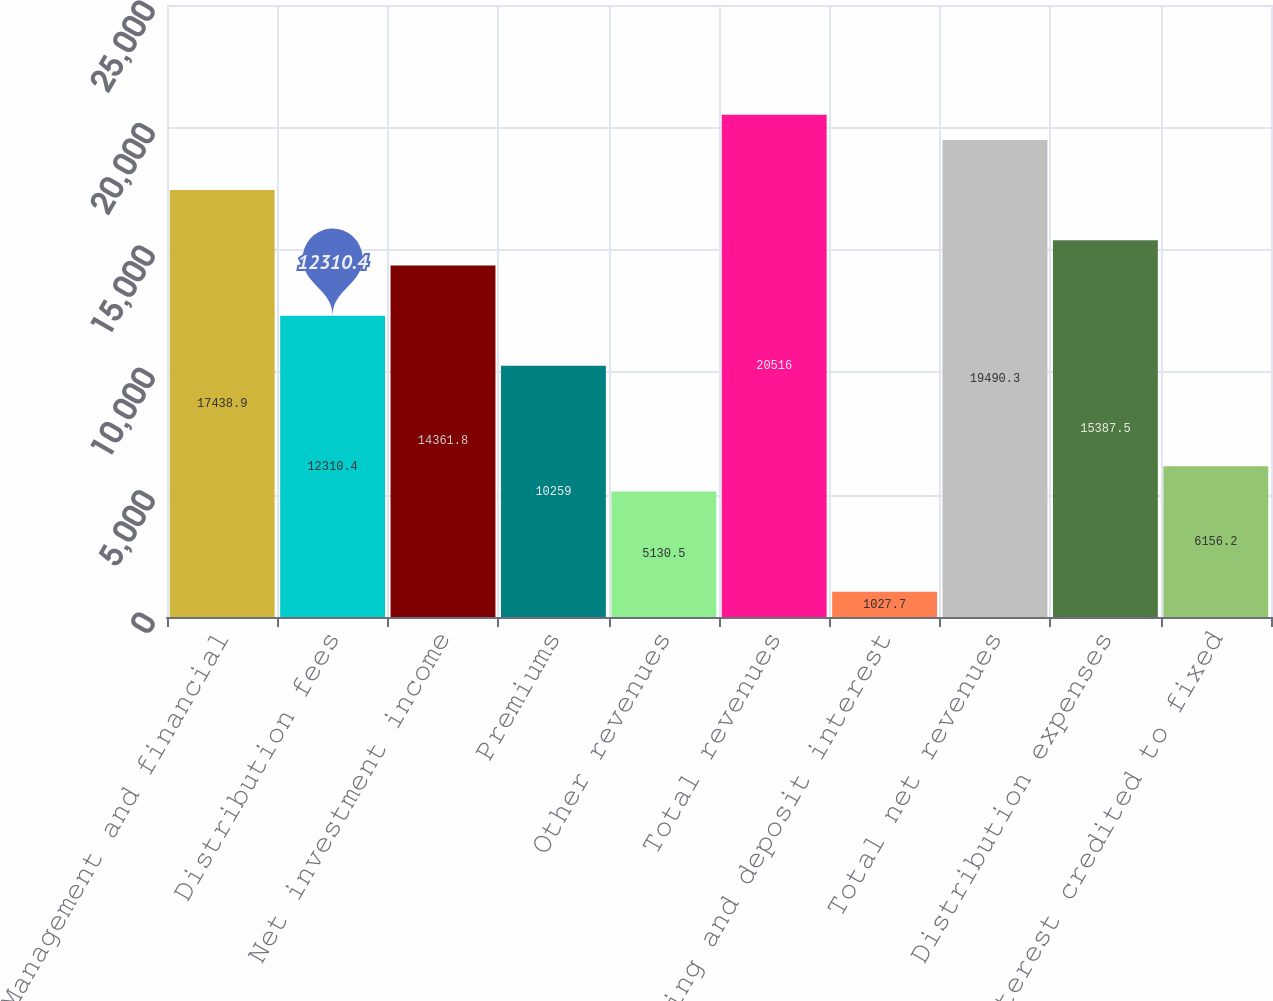Convert chart. <chart><loc_0><loc_0><loc_500><loc_500><bar_chart><fcel>Management and financial<fcel>Distribution fees<fcel>Net investment income<fcel>Premiums<fcel>Other revenues<fcel>Total revenues<fcel>Banking and deposit interest<fcel>Total net revenues<fcel>Distribution expenses<fcel>Interest credited to fixed<nl><fcel>17438.9<fcel>12310.4<fcel>14361.8<fcel>10259<fcel>5130.5<fcel>20516<fcel>1027.7<fcel>19490.3<fcel>15387.5<fcel>6156.2<nl></chart> 